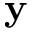<formula> <loc_0><loc_0><loc_500><loc_500>y</formula> 